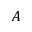Convert formula to latex. <formula><loc_0><loc_0><loc_500><loc_500>A</formula> 